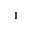<formula> <loc_0><loc_0><loc_500><loc_500>^ { 1 }</formula> 